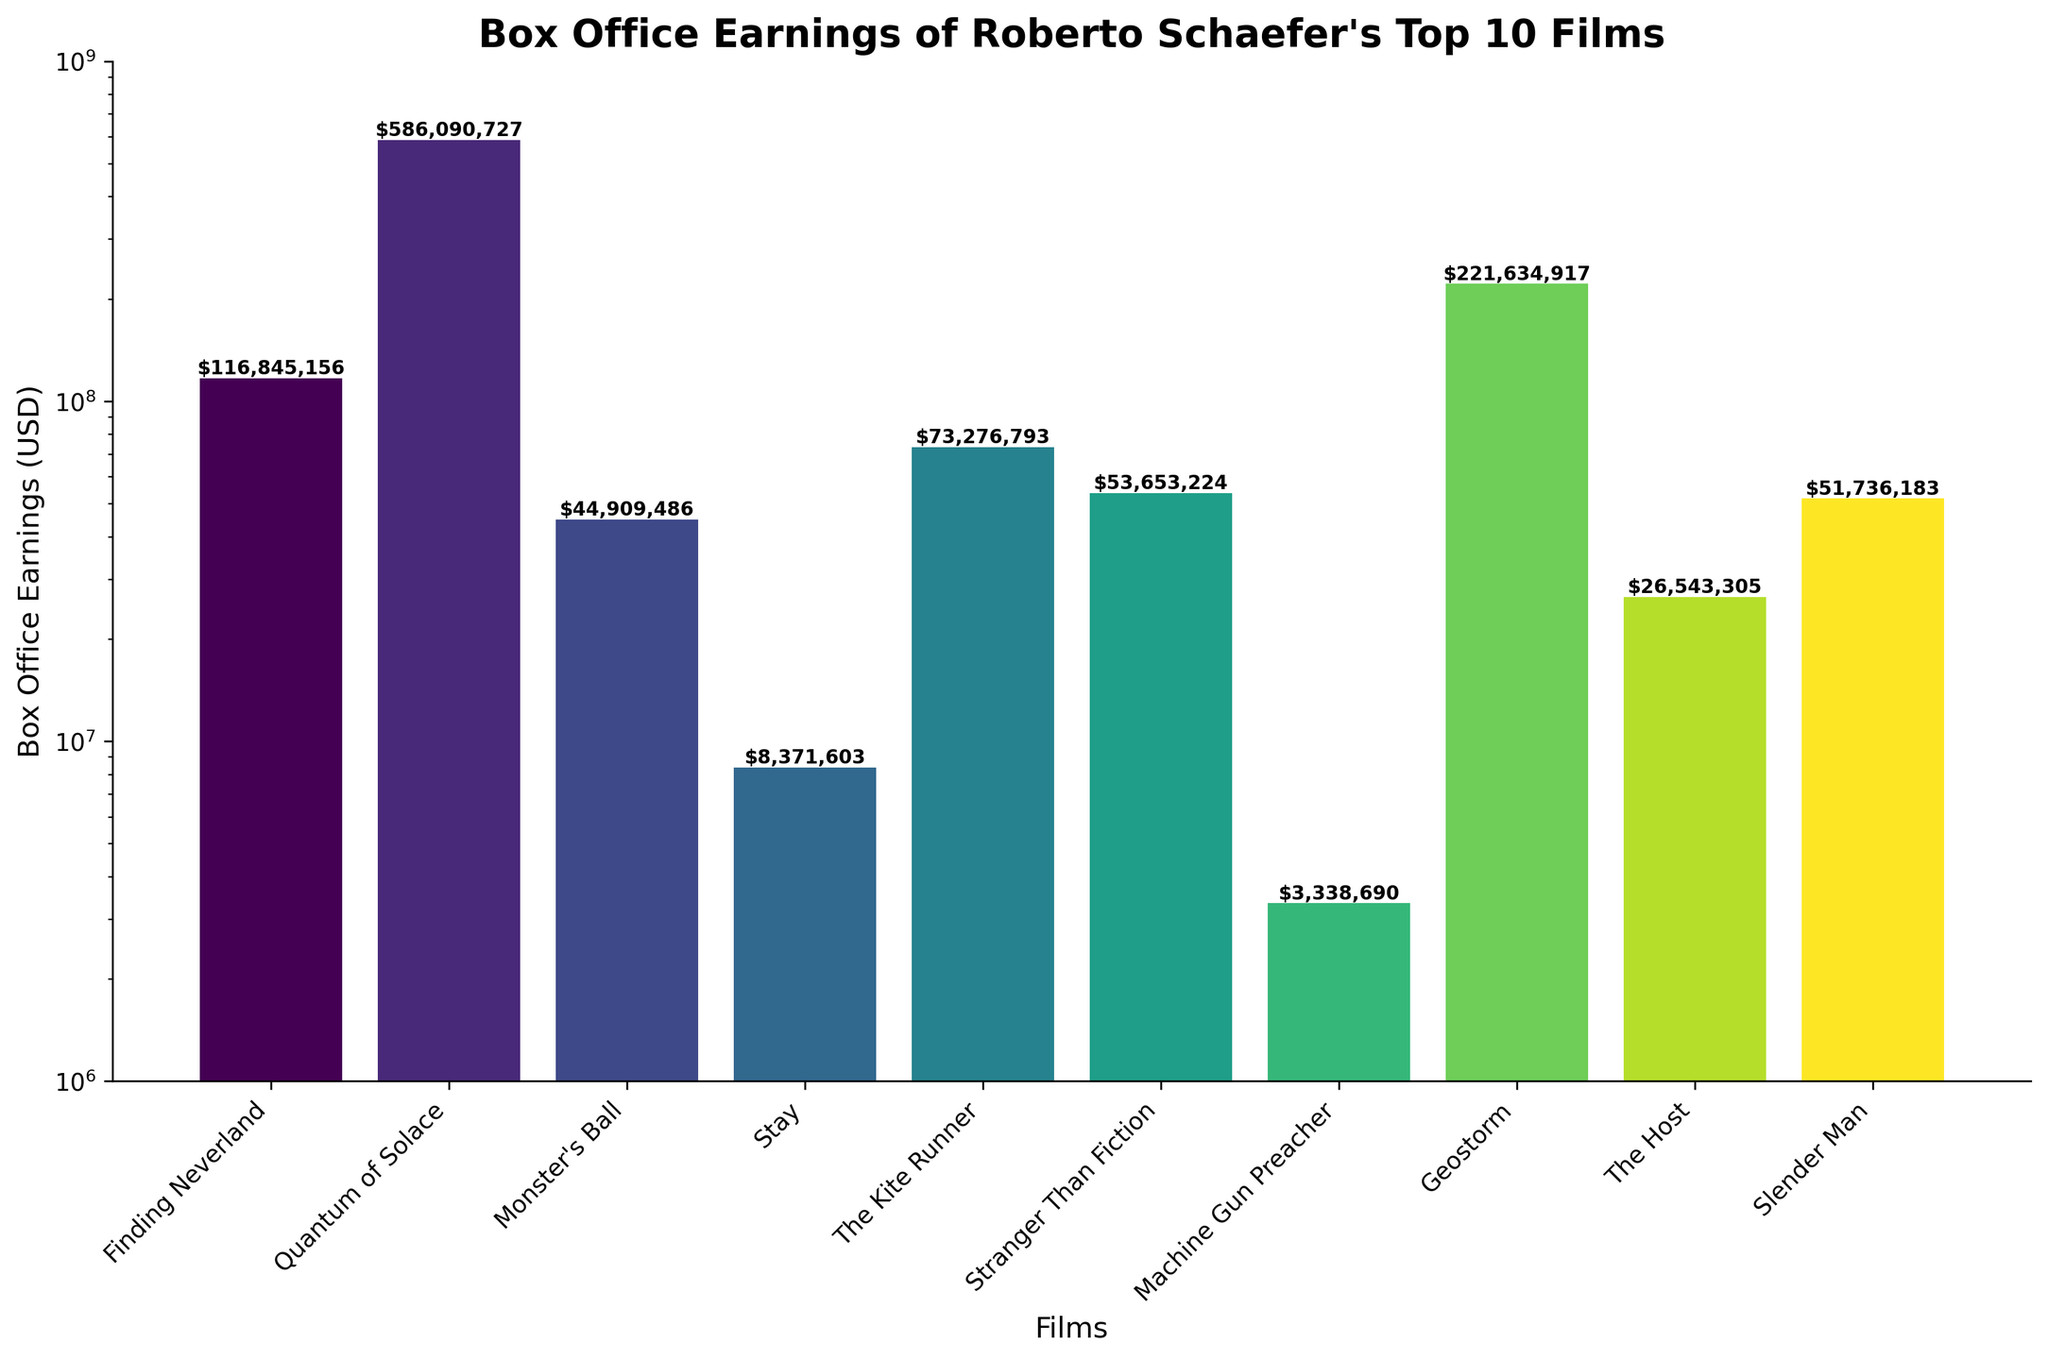Which film has the highest box office earnings? The highest bar represents the film "Quantum of Solace", which is the first step to identifying it as the movie with the highest earnings. By locating the tallest bar and checking its label, we confirm "Quantum of Solace" as the film with the highest earnings.
Answer: Quantum of Solace What is the difference in box office earnings between "Finding Neverland" and "The Kite Runner"? From the values on the bars, the box office earnings for "Finding Neverland" is $116,845,156 and for "The Kite Runner" is $73,276,793. Calculating the difference, we get $116,845,156 - $73,276,793 = $43,568,363.
Answer: $43,568,363 Which films earned less than $10,000,000 at the box office? By examining the height of the bars and the figures above each one, we see that "Stay" earned $8,371,603 and "Machine Gun Preacher" earned $3,338,690. Both amounts are less than $10,000,000.
Answer: Stay, Machine Gun Preacher Rank the films "Stranger Than Fiction", "Slender Man", and "Geostorm" from highest to lowest earnings. Comparing the heights of the bars, "Geostorm" has the highest earnings at $221,634,917 followed by "Slender Man" at $51,736,183 and "Stranger Than Fiction" at $53,653,224. So, the order from highest to lowest is: Geostorm, Stranger Than Fiction, Slender Man.
Answer: Geostorm, Stranger Than Fiction, Slender Man What is the average box office earnings of the films "Monster's Ball", "The Host", and "Stay"? Summing up their earnings: $44,909,486 (Monster's Ball) + $26,543,305 (The Host) + $8,371,603 (Stay) = $79,824,394. Dividing by 3 films, $79,824,394 / 3 = $26,608,131.33.
Answer: $26,608,131.33 How much more did "Quantum of Solace" earn compared to "Geostorm"? "Quantum of Solace" earned $586,090,727 and "Geostorm" earned $221,634,917. The difference is $586,090,727 - $221,634,917 = $364,455,810.
Answer: $364,455,810 Which film has the lowest box office earnings? The shortest bar indicates the lowest earnings, which corresponds to the film "Machine Gun Preacher" with $3,338,690 earnings.
Answer: Machine Gun Preacher What are the total box office earnings of all films combined? Summing the earnings for all films, we get: $116,845,156 + $586,090,727 + $44,909,486 + $8,371,603 + $73,276,793 + $53,653,224 + $3,338,690 + $221,634,917 + $26,543,305 + $51,736,183, which equals $1,186,400,084.
Answer: $1,186,400,084 